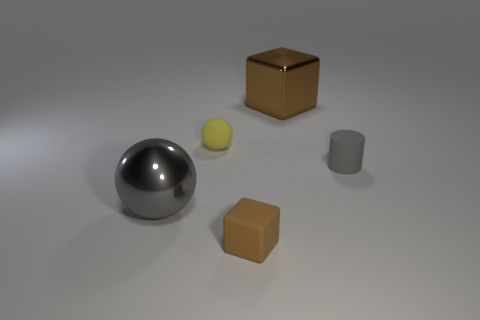If I were to put these objects in order from smallest to largest, what would that look like? Beginning with the smallest object, the order would be: the yellow sphere, the gray cylinder, the brown cube on the right, the brown cube on the left, and the largest being the metallic sphere. 